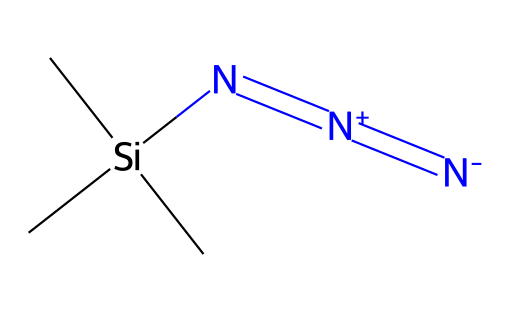What is the molecular formula of trimethylsilyl azide? To find the molecular formula, we count the elements in the SMILES representation. There are 3 carbon atoms (C), 9 hydrogen atoms (H), 1 silicon atom (Si), and 3 nitrogen atoms (N). Therefore, the molecular formula is derived as C3H9N3Si.
Answer: C3H9N3Si How many nitrogen atoms are present in trimethylsilyl azide? In the SMILES representation, the string contains three instances of 'N', indicating that there are three nitrogen atoms.
Answer: 3 What type of bonds are present between nitrogen atoms in trimethylsilyl azide? The SMILES notation shows a sequence of nitrogen atoms connected with '=[N+]=[N-]'. This suggests that there are two double bonds between the nitrogen atoms, indicating that the bonds are covalent and specifically handle positive and negative charges.
Answer: double bonds What does the presence of the silicon atom in trimethylsilyl azide suggest about its stability? The silicon atom is part of a trimethylsilyl group, which typically enhances the stability of the azide group due to the electron-donating nature of the silicon atom. This interaction often makes the overall compound more stable compared to other azides without such groups.
Answer: enhances stability Which functional group is characteristic of azides, as seen in trimethylsilyl azide? Azides are characterized by the functional group -N3. In the structure provided, this can be identified in the nitrogen arrangement – specifically the connected nitrogen atoms that form the azide portion of the molecule.
Answer: -N3 What is the significance of the trimethylsilyl group in organic synthesis for azides? The trimethylsilyl group is often used in organic chemistry to protect functional groups and increase the solubility of azide compounds in organic solvents, aiding their reactivity and utilization in synthetic pathways and reactions.
Answer: increases solubility 